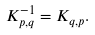<formula> <loc_0><loc_0><loc_500><loc_500>K _ { p , q } ^ { - 1 } = K _ { q , p } .</formula> 